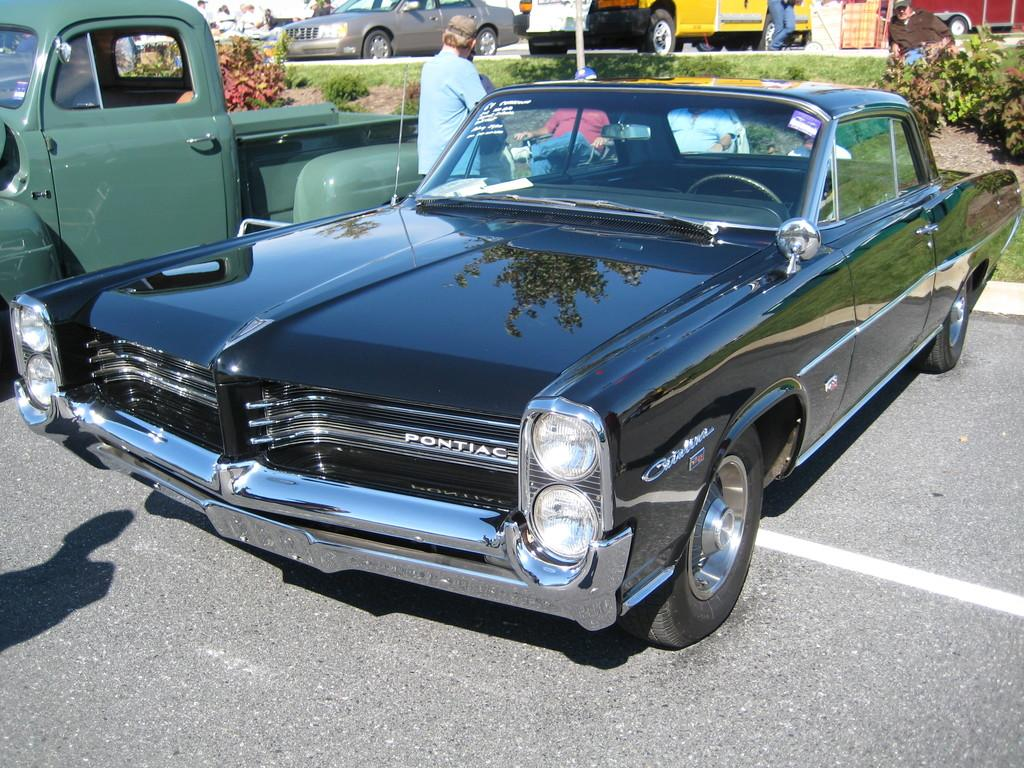What type of vehicles can be seen on the road in the image? There are cars on the road in the image. Who or what else is present in the image besides the cars? There are people and plants in the image. What structure can be seen in the image? There is a pole in the image. Can you tell me how many crates are stacked next to the pole in the image? There are no crates present in the image; it features cars on the road, people, plants, and a pole. What type of snake can be seen slithering through the plants in the image? There is no snake present in the image; it only features cars, people, plants, and a pole. 